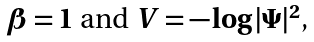Convert formula to latex. <formula><loc_0><loc_0><loc_500><loc_500>\text {$\beta=1$ and $V=-\log |\Psi|^{2}$,}</formula> 